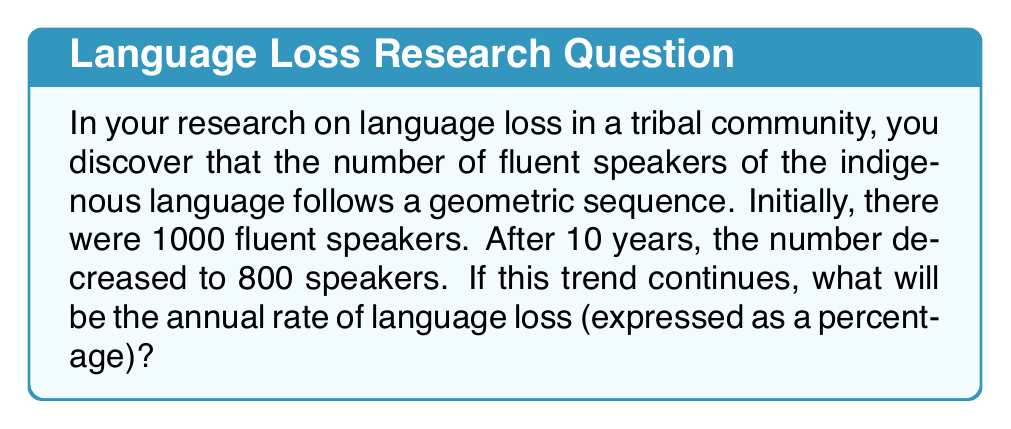Could you help me with this problem? Let's approach this step-by-step:

1) In a geometric sequence, each term is a constant multiple of the previous term. Let's call this constant $r$. In this case, $r$ represents the rate at which the number of speakers changes each year.

2) We can express this relationship as:
   $$800 = 1000 \cdot r^{10}$$

3) To solve for $r$, we divide both sides by 1000:
   $$0.8 = r^{10}$$

4) Now, we take the 10th root of both sides:
   $$r = \sqrt[10]{0.8}$$

5) Using a calculator or computer, we can evaluate this:
   $$r \approx 0.9778$$

6) This means that each year, the number of speakers is approximately 97.78% of what it was the previous year.

7) To find the rate of loss, we subtract this from 1 and convert to a percentage:
   $$(1 - 0.9778) \cdot 100\% \approx 2.22\%$$

Therefore, the annual rate of language loss is approximately 2.22%.
Answer: 2.22% 